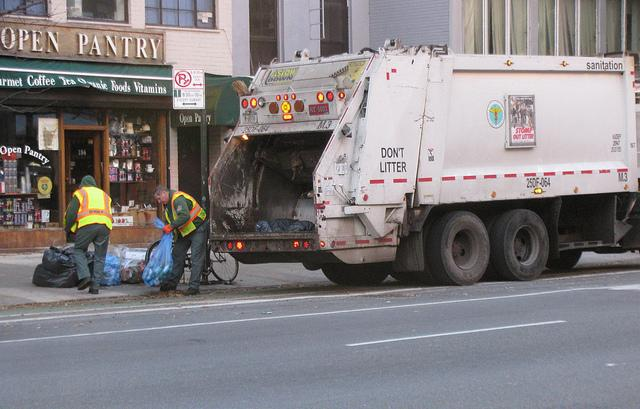Why are the men wearing yellow vests?

Choices:
A) as punishment
B) for fun
C) visibility
D) fashion visibility 